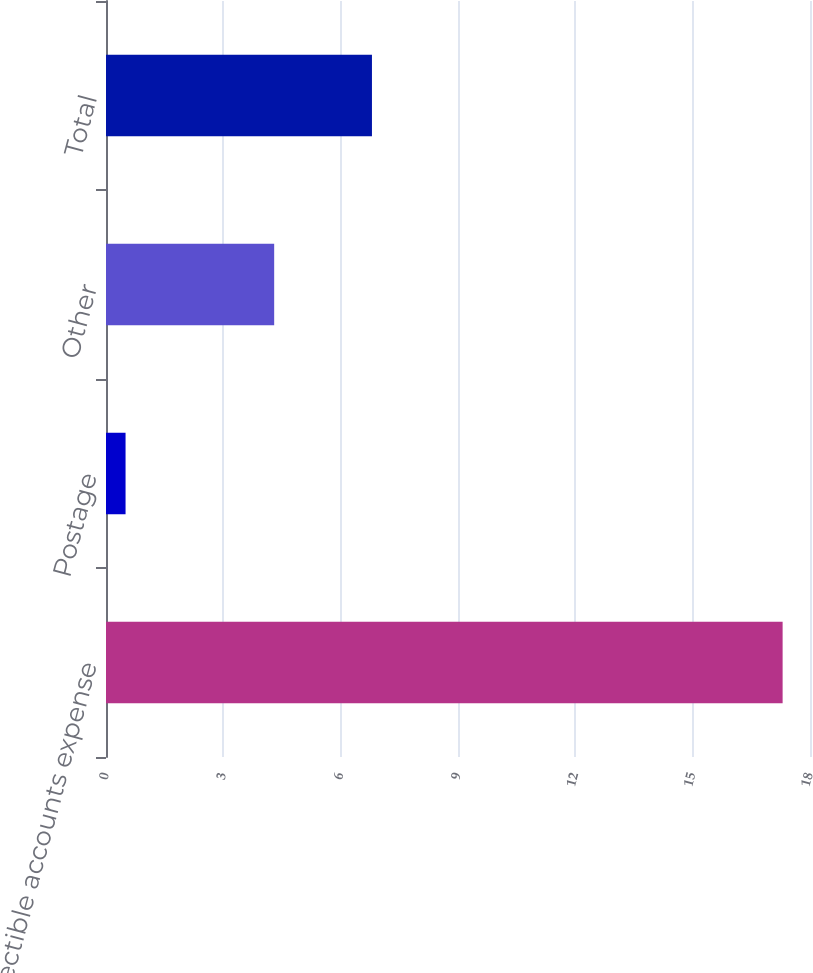<chart> <loc_0><loc_0><loc_500><loc_500><bar_chart><fcel>Uncollectible accounts expense<fcel>Postage<fcel>Other<fcel>Total<nl><fcel>17.3<fcel>0.5<fcel>4.3<fcel>6.8<nl></chart> 